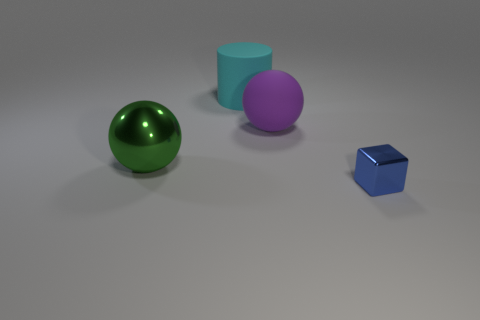Add 2 tiny green things. How many objects exist? 6 Subtract all cylinders. How many objects are left? 3 Subtract all brown blocks. Subtract all large cyan matte cylinders. How many objects are left? 3 Add 4 shiny blocks. How many shiny blocks are left? 5 Add 3 tiny yellow rubber spheres. How many tiny yellow rubber spheres exist? 3 Subtract 0 gray spheres. How many objects are left? 4 